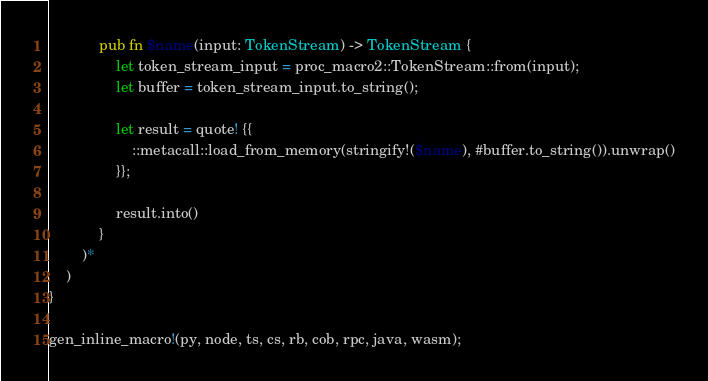<code> <loc_0><loc_0><loc_500><loc_500><_Rust_>            pub fn $name(input: TokenStream) -> TokenStream {
                let token_stream_input = proc_macro2::TokenStream::from(input);
                let buffer = token_stream_input.to_string();

                let result = quote! {{
                    ::metacall::load_from_memory(stringify!($name), #buffer.to_string()).unwrap()
                }};

                result.into()
            }
        )*
    )
}

gen_inline_macro!(py, node, ts, cs, rb, cob, rpc, java, wasm);
</code> 